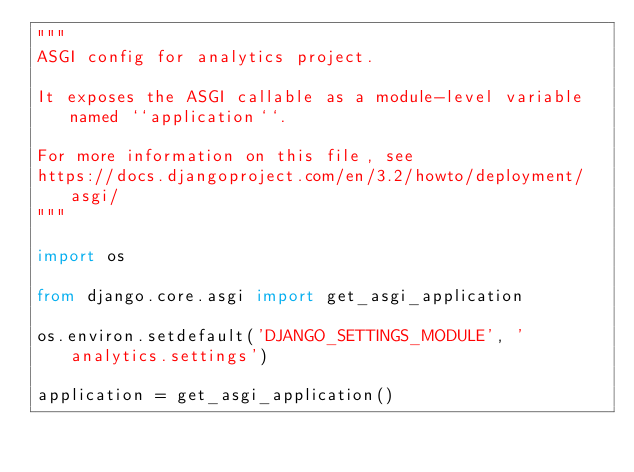Convert code to text. <code><loc_0><loc_0><loc_500><loc_500><_Python_>"""
ASGI config for analytics project.

It exposes the ASGI callable as a module-level variable named ``application``.

For more information on this file, see
https://docs.djangoproject.com/en/3.2/howto/deployment/asgi/
"""

import os

from django.core.asgi import get_asgi_application

os.environ.setdefault('DJANGO_SETTINGS_MODULE', 'analytics.settings')

application = get_asgi_application()
</code> 